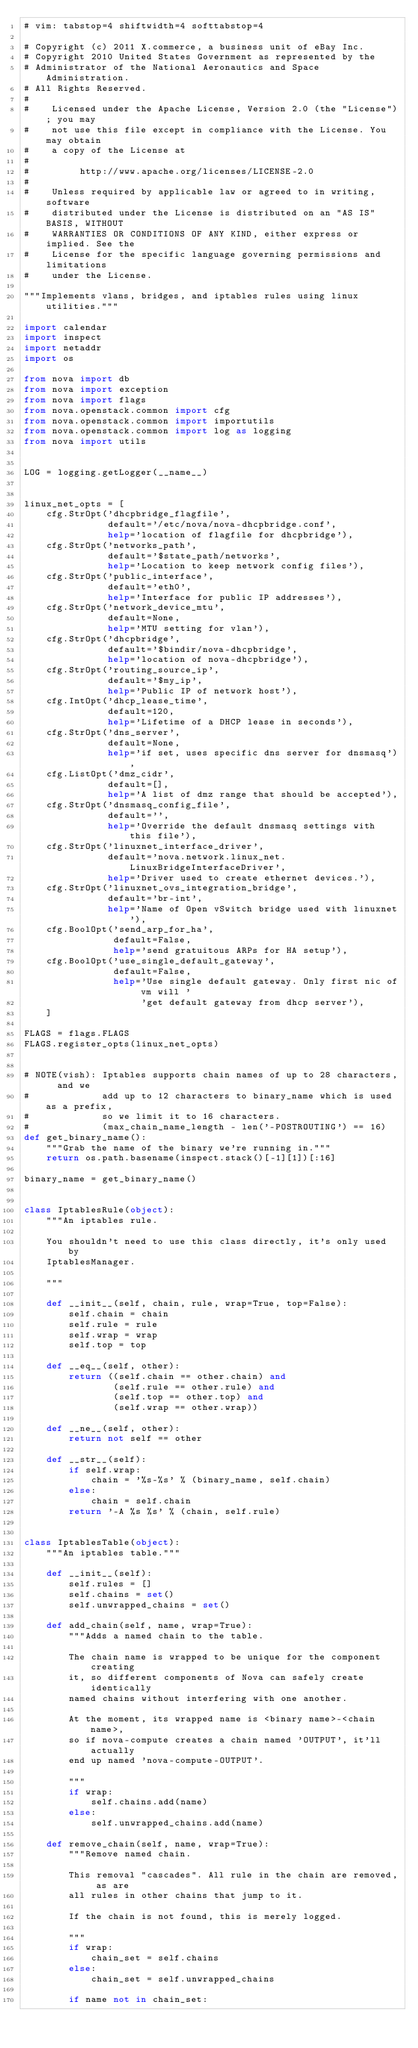<code> <loc_0><loc_0><loc_500><loc_500><_Python_># vim: tabstop=4 shiftwidth=4 softtabstop=4

# Copyright (c) 2011 X.commerce, a business unit of eBay Inc.
# Copyright 2010 United States Government as represented by the
# Administrator of the National Aeronautics and Space Administration.
# All Rights Reserved.
#
#    Licensed under the Apache License, Version 2.0 (the "License"); you may
#    not use this file except in compliance with the License. You may obtain
#    a copy of the License at
#
#         http://www.apache.org/licenses/LICENSE-2.0
#
#    Unless required by applicable law or agreed to in writing, software
#    distributed under the License is distributed on an "AS IS" BASIS, WITHOUT
#    WARRANTIES OR CONDITIONS OF ANY KIND, either express or implied. See the
#    License for the specific language governing permissions and limitations
#    under the License.

"""Implements vlans, bridges, and iptables rules using linux utilities."""

import calendar
import inspect
import netaddr
import os

from nova import db
from nova import exception
from nova import flags
from nova.openstack.common import cfg
from nova.openstack.common import importutils
from nova.openstack.common import log as logging
from nova import utils


LOG = logging.getLogger(__name__)


linux_net_opts = [
    cfg.StrOpt('dhcpbridge_flagfile',
               default='/etc/nova/nova-dhcpbridge.conf',
               help='location of flagfile for dhcpbridge'),
    cfg.StrOpt('networks_path',
               default='$state_path/networks',
               help='Location to keep network config files'),
    cfg.StrOpt('public_interface',
               default='eth0',
               help='Interface for public IP addresses'),
    cfg.StrOpt('network_device_mtu',
               default=None,
               help='MTU setting for vlan'),
    cfg.StrOpt('dhcpbridge',
               default='$bindir/nova-dhcpbridge',
               help='location of nova-dhcpbridge'),
    cfg.StrOpt('routing_source_ip',
               default='$my_ip',
               help='Public IP of network host'),
    cfg.IntOpt('dhcp_lease_time',
               default=120,
               help='Lifetime of a DHCP lease in seconds'),
    cfg.StrOpt('dns_server',
               default=None,
               help='if set, uses specific dns server for dnsmasq'),
    cfg.ListOpt('dmz_cidr',
               default=[],
               help='A list of dmz range that should be accepted'),
    cfg.StrOpt('dnsmasq_config_file',
               default='',
               help='Override the default dnsmasq settings with this file'),
    cfg.StrOpt('linuxnet_interface_driver',
               default='nova.network.linux_net.LinuxBridgeInterfaceDriver',
               help='Driver used to create ethernet devices.'),
    cfg.StrOpt('linuxnet_ovs_integration_bridge',
               default='br-int',
               help='Name of Open vSwitch bridge used with linuxnet'),
    cfg.BoolOpt('send_arp_for_ha',
                default=False,
                help='send gratuitous ARPs for HA setup'),
    cfg.BoolOpt('use_single_default_gateway',
                default=False,
                help='Use single default gateway. Only first nic of vm will '
                     'get default gateway from dhcp server'),
    ]

FLAGS = flags.FLAGS
FLAGS.register_opts(linux_net_opts)


# NOTE(vish): Iptables supports chain names of up to 28 characters,  and we
#             add up to 12 characters to binary_name which is used as a prefix,
#             so we limit it to 16 characters.
#             (max_chain_name_length - len('-POSTROUTING') == 16)
def get_binary_name():
    """Grab the name of the binary we're running in."""
    return os.path.basename(inspect.stack()[-1][1])[:16]

binary_name = get_binary_name()


class IptablesRule(object):
    """An iptables rule.

    You shouldn't need to use this class directly, it's only used by
    IptablesManager.

    """

    def __init__(self, chain, rule, wrap=True, top=False):
        self.chain = chain
        self.rule = rule
        self.wrap = wrap
        self.top = top

    def __eq__(self, other):
        return ((self.chain == other.chain) and
                (self.rule == other.rule) and
                (self.top == other.top) and
                (self.wrap == other.wrap))

    def __ne__(self, other):
        return not self == other

    def __str__(self):
        if self.wrap:
            chain = '%s-%s' % (binary_name, self.chain)
        else:
            chain = self.chain
        return '-A %s %s' % (chain, self.rule)


class IptablesTable(object):
    """An iptables table."""

    def __init__(self):
        self.rules = []
        self.chains = set()
        self.unwrapped_chains = set()

    def add_chain(self, name, wrap=True):
        """Adds a named chain to the table.

        The chain name is wrapped to be unique for the component creating
        it, so different components of Nova can safely create identically
        named chains without interfering with one another.

        At the moment, its wrapped name is <binary name>-<chain name>,
        so if nova-compute creates a chain named 'OUTPUT', it'll actually
        end up named 'nova-compute-OUTPUT'.

        """
        if wrap:
            self.chains.add(name)
        else:
            self.unwrapped_chains.add(name)

    def remove_chain(self, name, wrap=True):
        """Remove named chain.

        This removal "cascades". All rule in the chain are removed, as are
        all rules in other chains that jump to it.

        If the chain is not found, this is merely logged.

        """
        if wrap:
            chain_set = self.chains
        else:
            chain_set = self.unwrapped_chains

        if name not in chain_set:</code> 